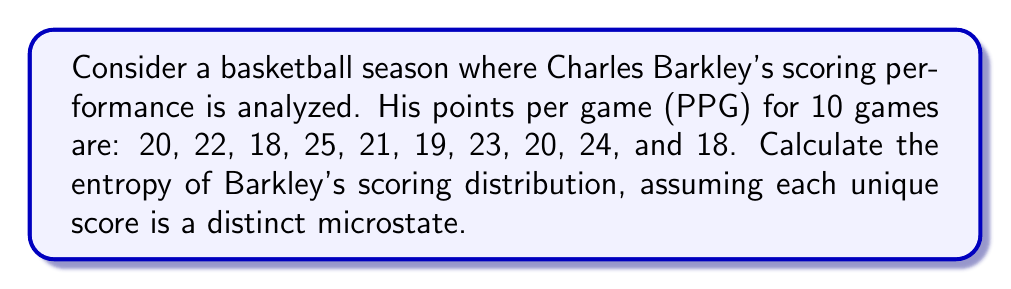Can you answer this question? To calculate the entropy of Barkley's scoring distribution, we'll follow these steps:

1. Identify unique scores and their frequencies:
   18 PPG: 2 times
   19 PPG: 1 time
   20 PPG: 2 times
   21 PPG: 1 time
   22 PPG: 1 time
   23 PPG: 1 time
   24 PPG: 1 time
   25 PPG: 1 time

2. Calculate the probability of each unique score:
   $p(18) = 2/10 = 0.2$
   $p(19) = 1/10 = 0.1$
   $p(20) = 2/10 = 0.2$
   $p(21) = 1/10 = 0.1$
   $p(22) = 1/10 = 0.1$
   $p(23) = 1/10 = 0.1$
   $p(24) = 1/10 = 0.1$
   $p(25) = 1/10 = 0.1$

3. Use the entropy formula:
   $$S = -k_B \sum_{i} p_i \ln(p_i)$$
   where $k_B$ is Boltzmann's constant. For this calculation, we'll use $k_B = 1$ for simplicity.

4. Calculate the entropy:
   $$\begin{align}
   S &= -[(0.2 \ln(0.2)) + (0.1 \ln(0.1)) + (0.2 \ln(0.2)) \\
     &+ (0.1 \ln(0.1)) + (0.1 \ln(0.1)) + (0.1 \ln(0.1)) \\
     &+ (0.1 \ln(0.1)) + (0.1 \ln(0.1))]
   \end{align}$$

5. Simplify:
   $$\begin{align}
   S &= -[2(0.2 \ln(0.2)) + 6(0.1 \ln(0.1))] \\
     &= -[2(-0.3219) + 6(-0.2303)] \\
     &= 0.6438 + 1.3818 \\
     &= 2.0256
   \end{align}$$
Answer: $2.0256$ 